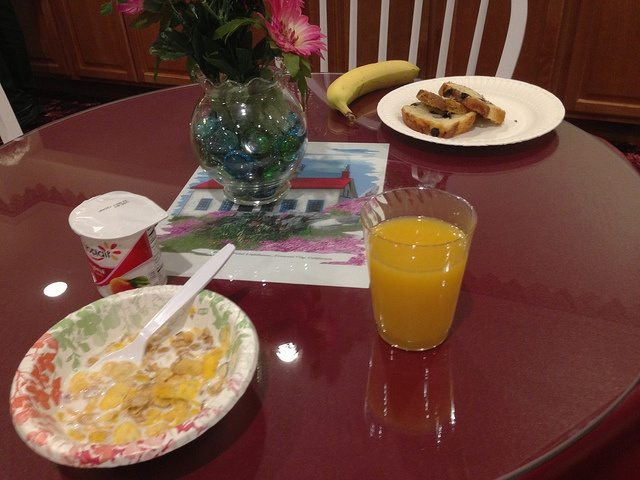Describe the objects in this image and their specific colors. I can see dining table in black, maroon, and brown tones, bowl in black and tan tones, cup in black, olive, orange, and maroon tones, chair in black, maroon, darkgray, and gray tones, and vase in black, gray, and darkgreen tones in this image. 